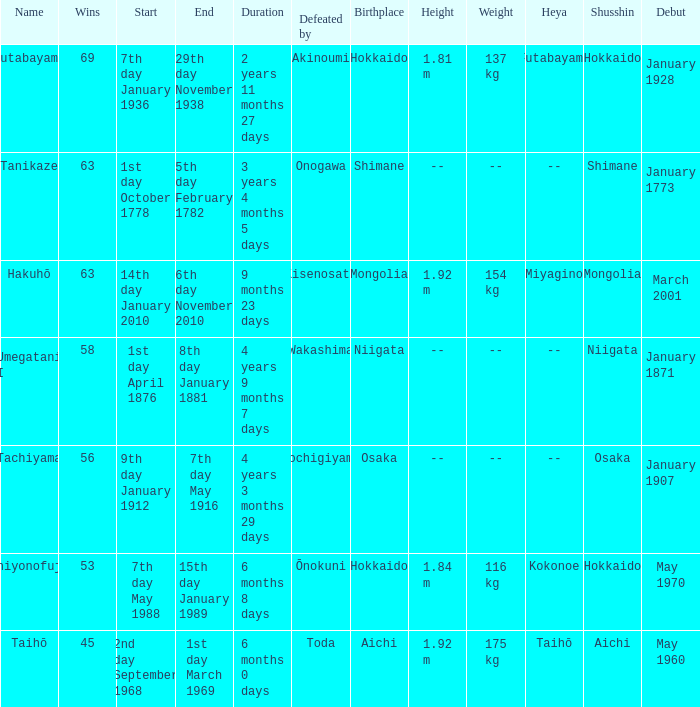What is the Duration for less than 53 consecutive wins? 6 months 0 days. 